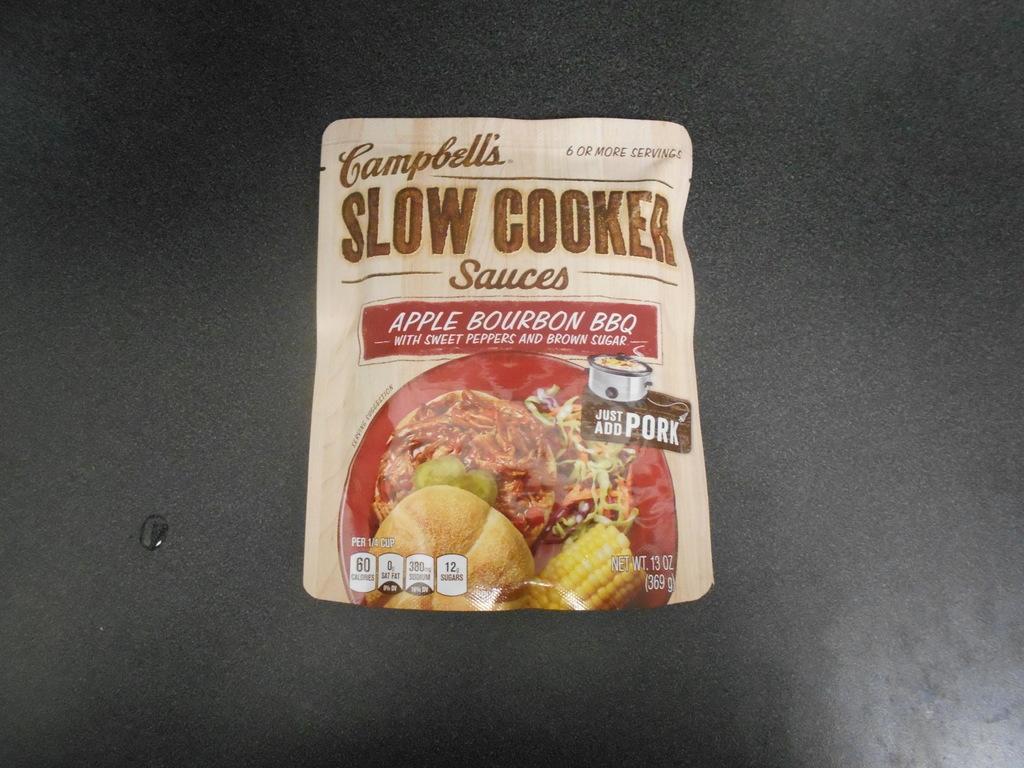How would you summarize this image in a sentence or two? In the center of the image a packet is present on the black surface. On the left side of the image a water is there. 